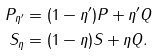Convert formula to latex. <formula><loc_0><loc_0><loc_500><loc_500>P _ { \eta ^ { \prime } } & = ( 1 - \eta ^ { \prime } ) P + \eta ^ { \prime } Q \\ S _ { \eta } & = ( 1 - \eta ) S + \eta Q .</formula> 